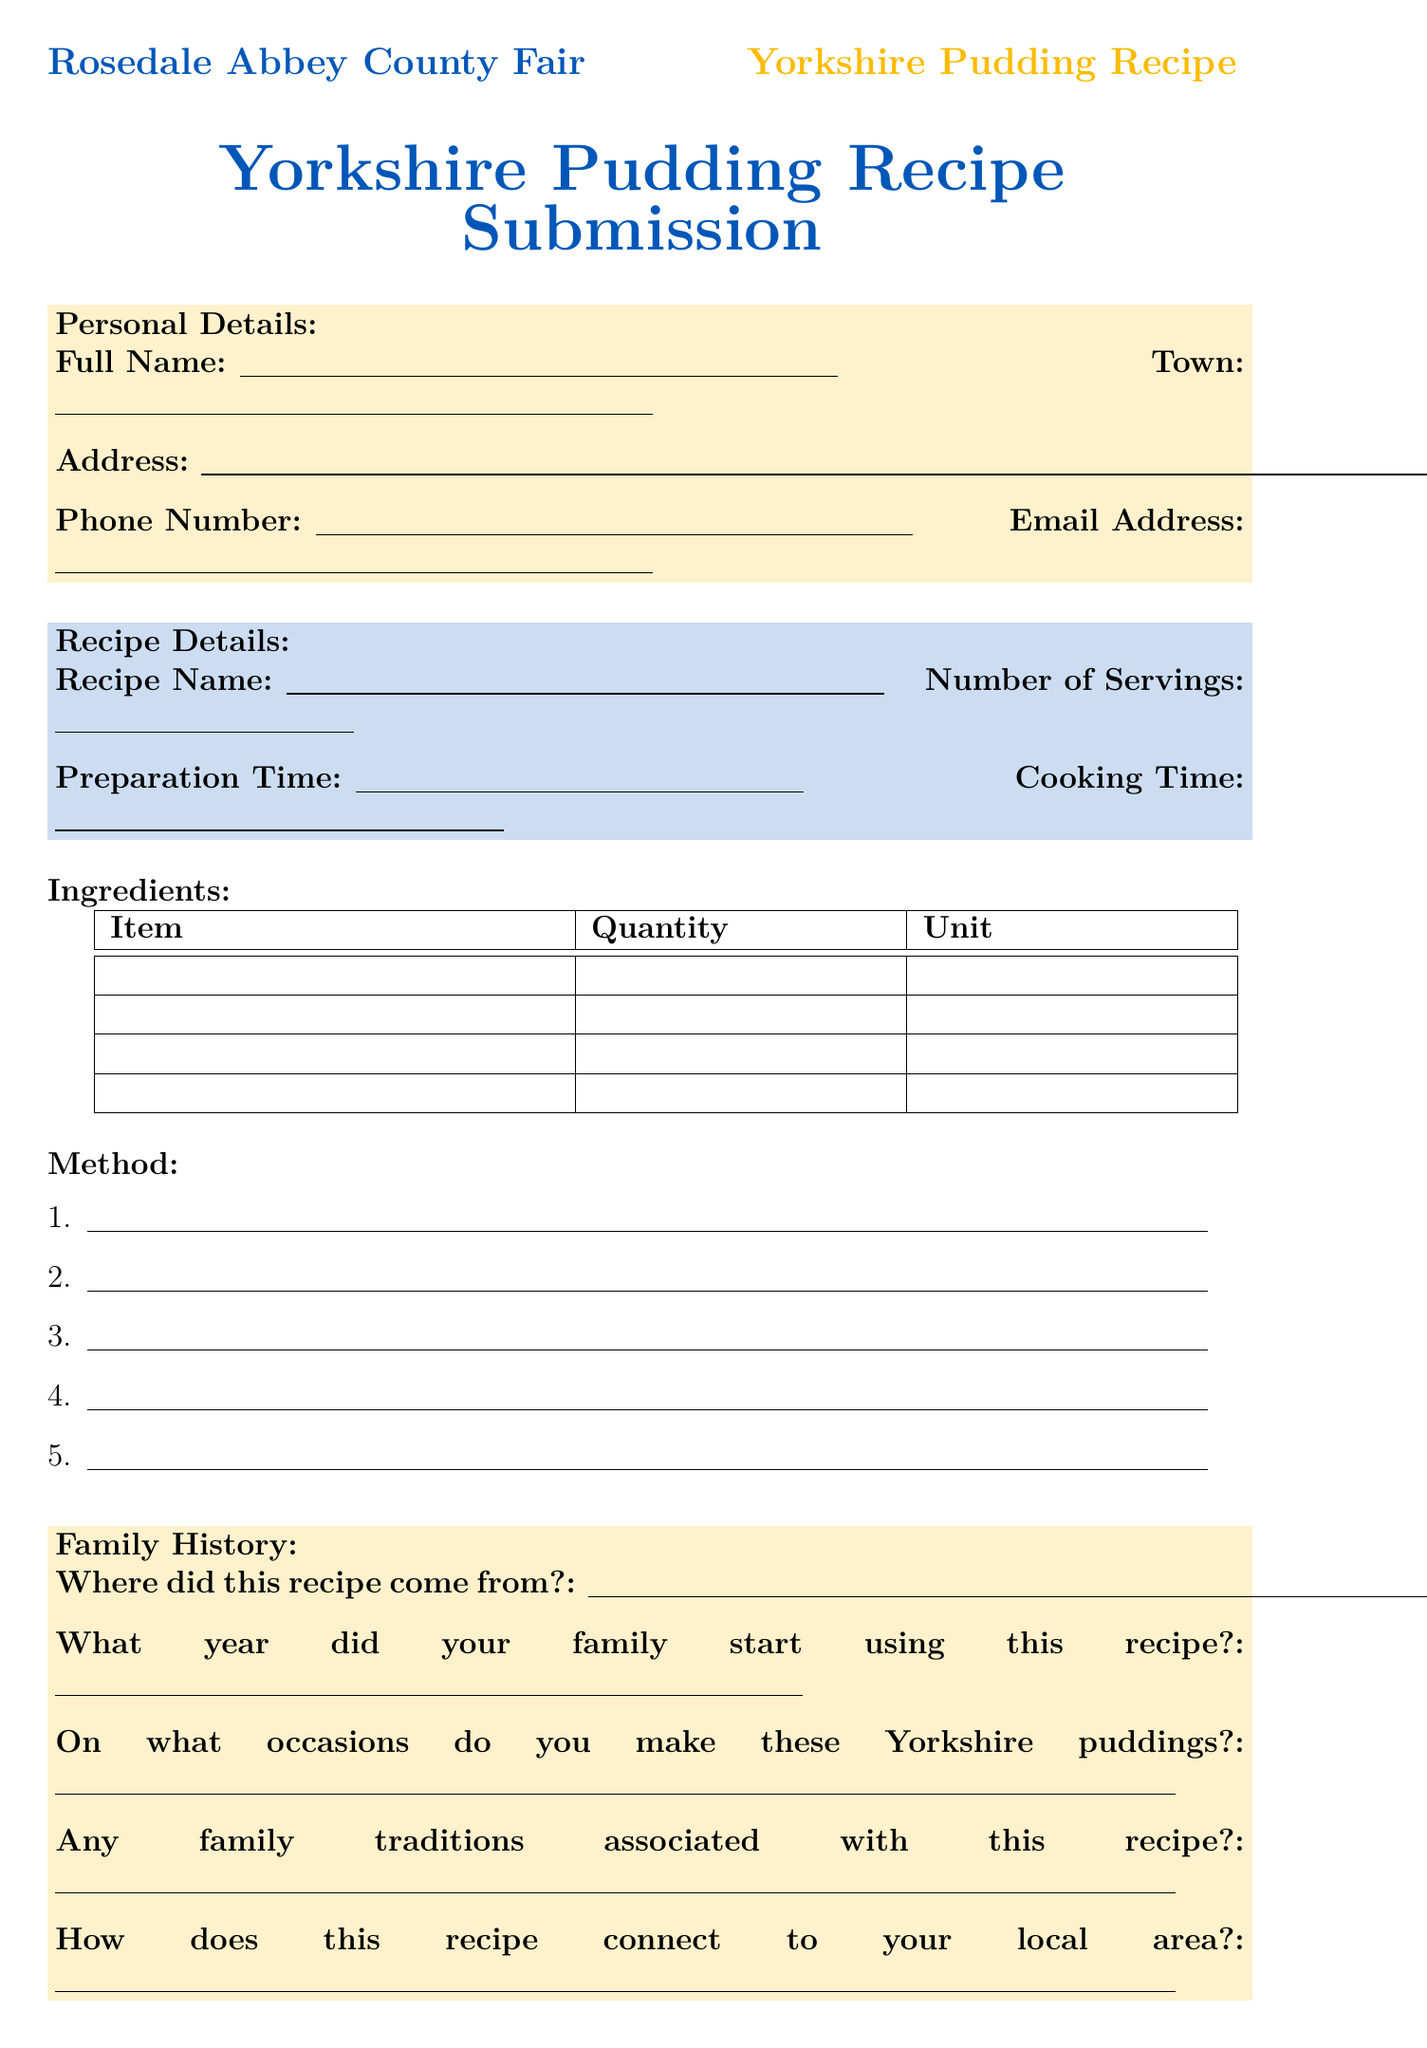what is the title of the form? The title of the form is clearly stated at the top of the document.
Answer: Yorkshire Pudding Recipe Submission - Rosedale Abbey County Fair what details are required in the personal information section? The personal information section includes various fields that need to be filled in.
Answer: Full Name, Address, Town, Phone Number, Email Address how many servings does the recipe yield? The number of servings is specified in the recipe details section of the form.
Answer: Number of Servings what is the cooking time required for the recipe? The cooking time can be found in the recipe details section, alongside the preparation time.
Answer: Cooking Time who is the recipe origin attributed to in the family history section? The family history section asks for the source of the recipe, indicating a specific family member.
Answer: Where did this recipe come from? what is needed for the declaration at the end of the form? The declaration requires a signature and a date, confirming the authenticity of the recipe submission.
Answer: Signature, Date what specific connection does the recipe have to the local area? The family history section includes a question that addresses local connections.
Answer: How does this recipe connect to your local area? what is one of the special tips provided in the document? The special tips section includes suggestions from the recipe creator on improving the pudding.
Answer: What's your secret to making the perfect Yorkshire pudding? in what year did the family start using this recipe? This information is requested in the family history section, asking for a specific number.
Answer: What year did your family start using this recipe? 